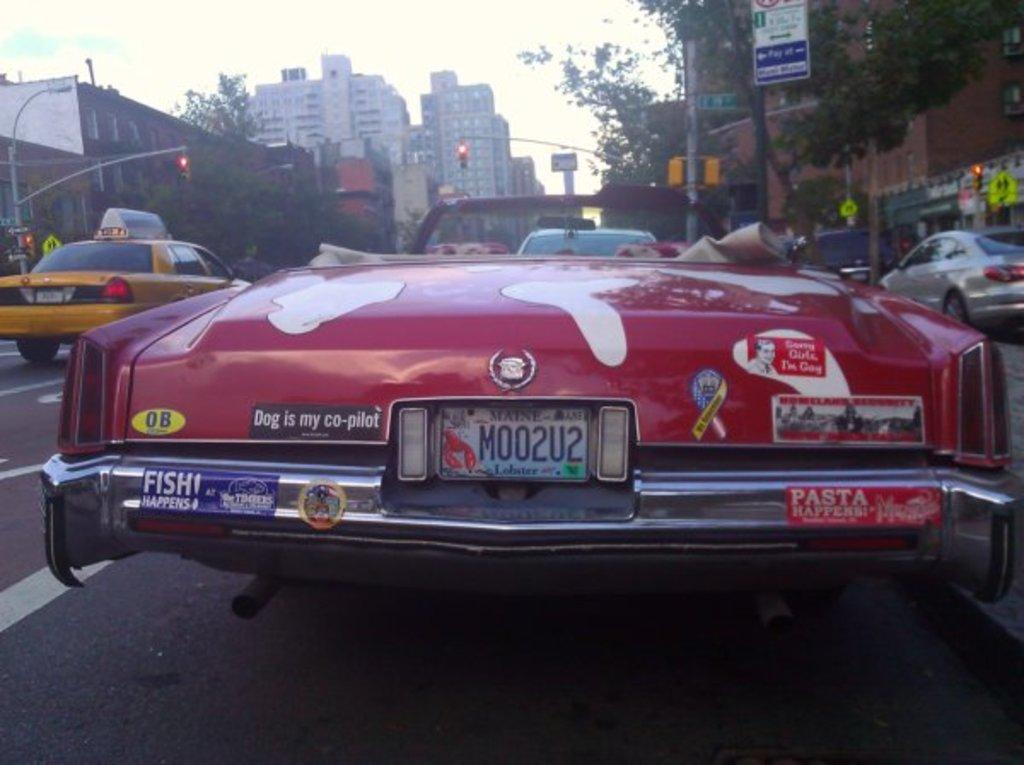<image>
Summarize the visual content of the image. a license plate with m002u2 on the back 